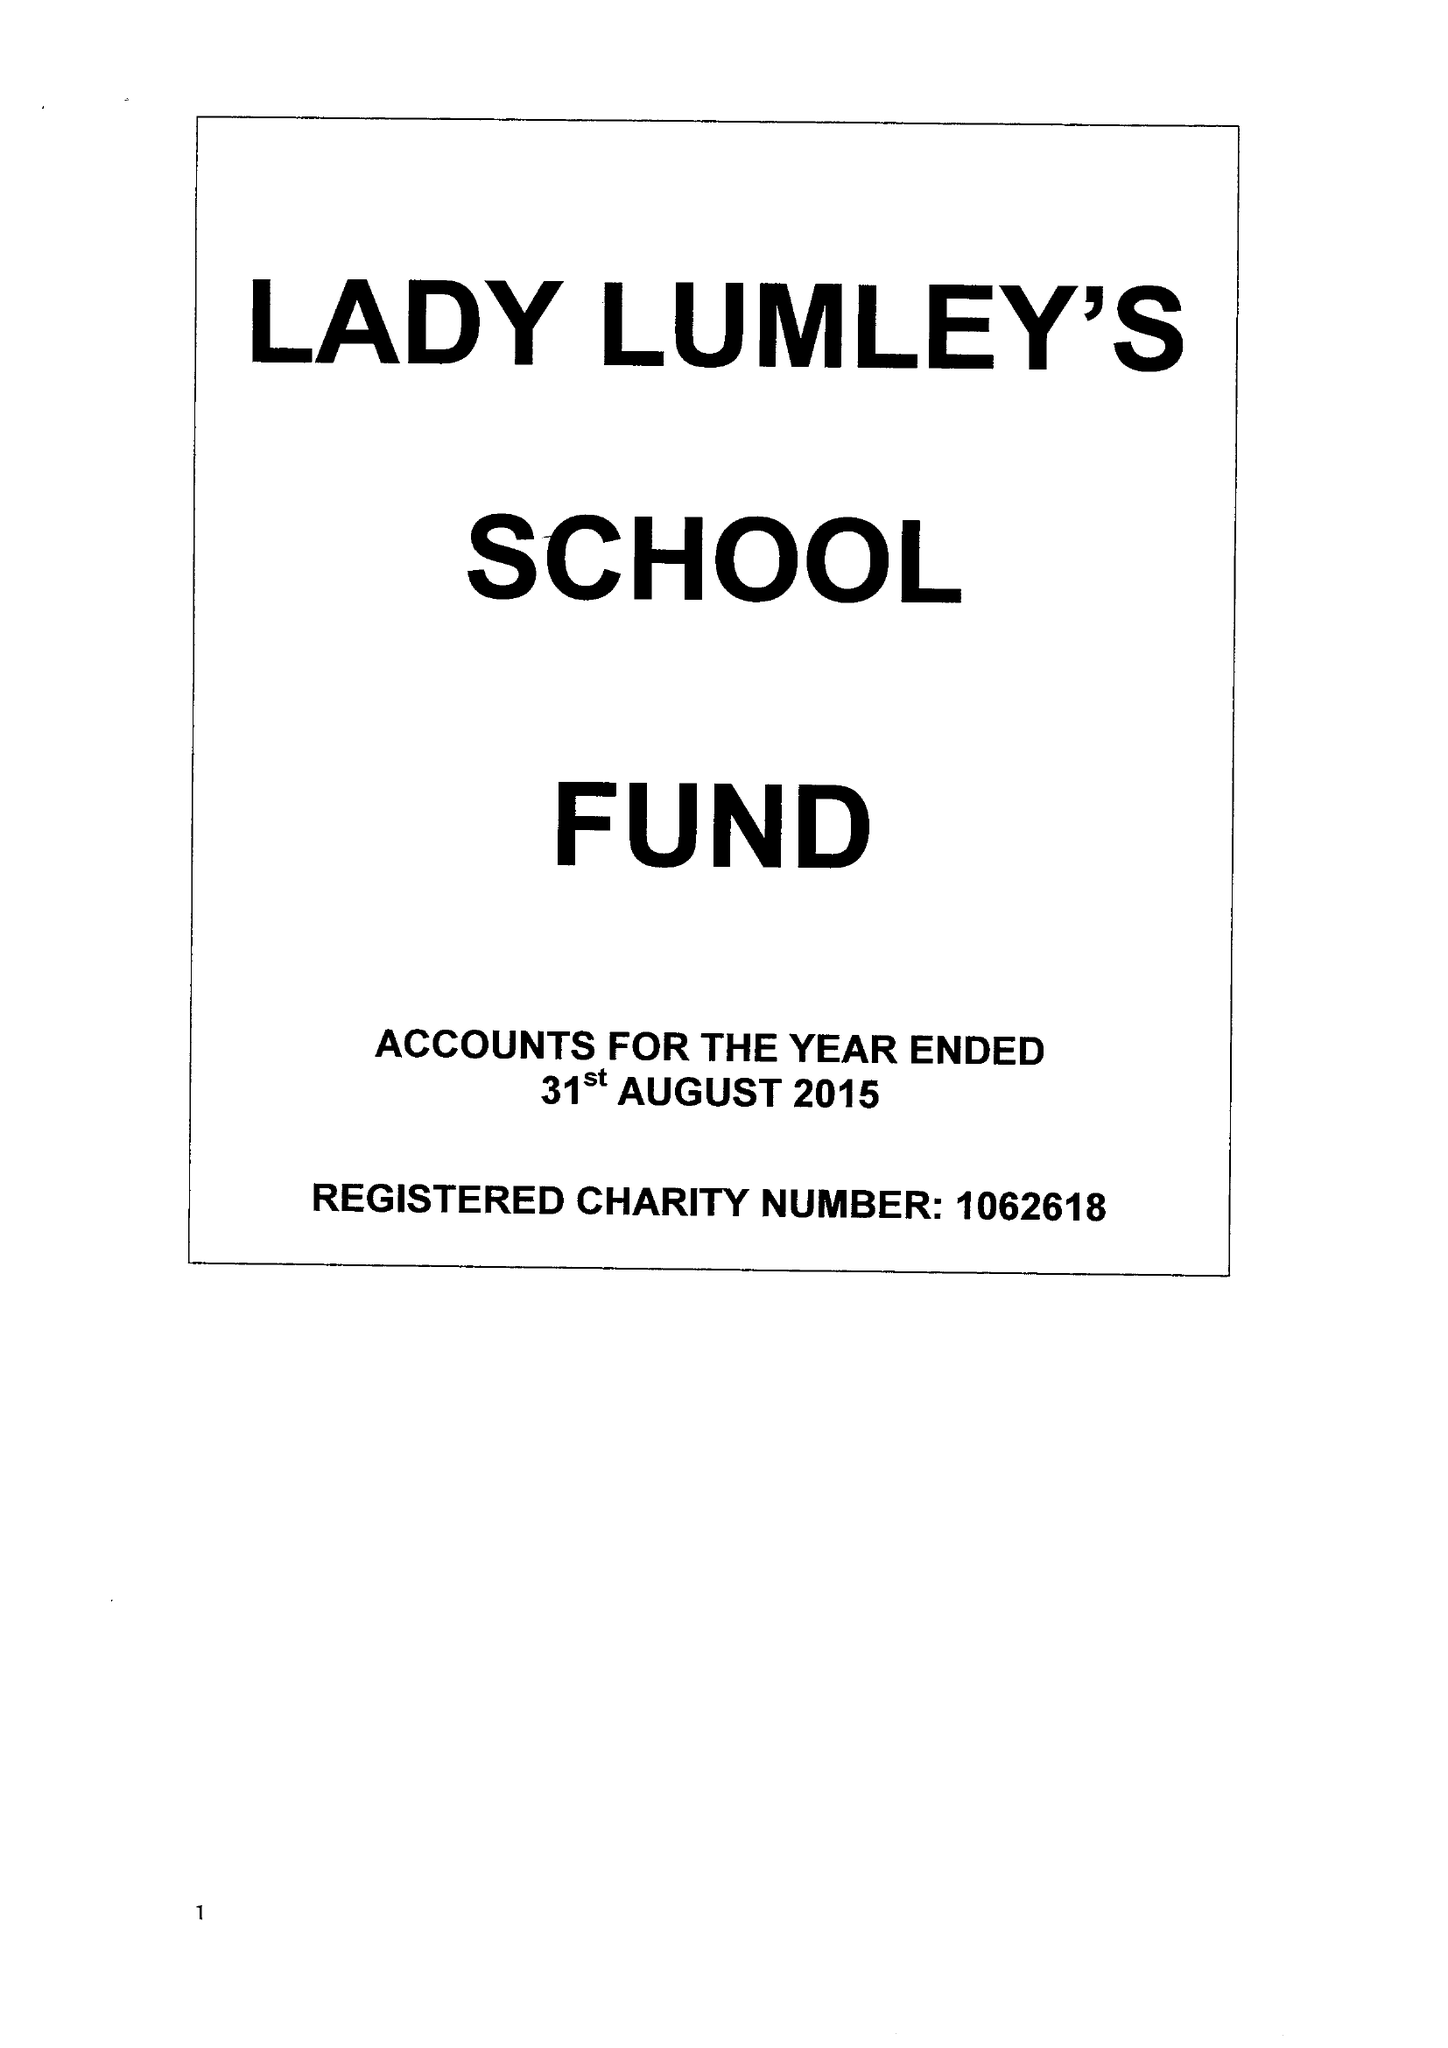What is the value for the address__post_town?
Answer the question using a single word or phrase. PICKERING 